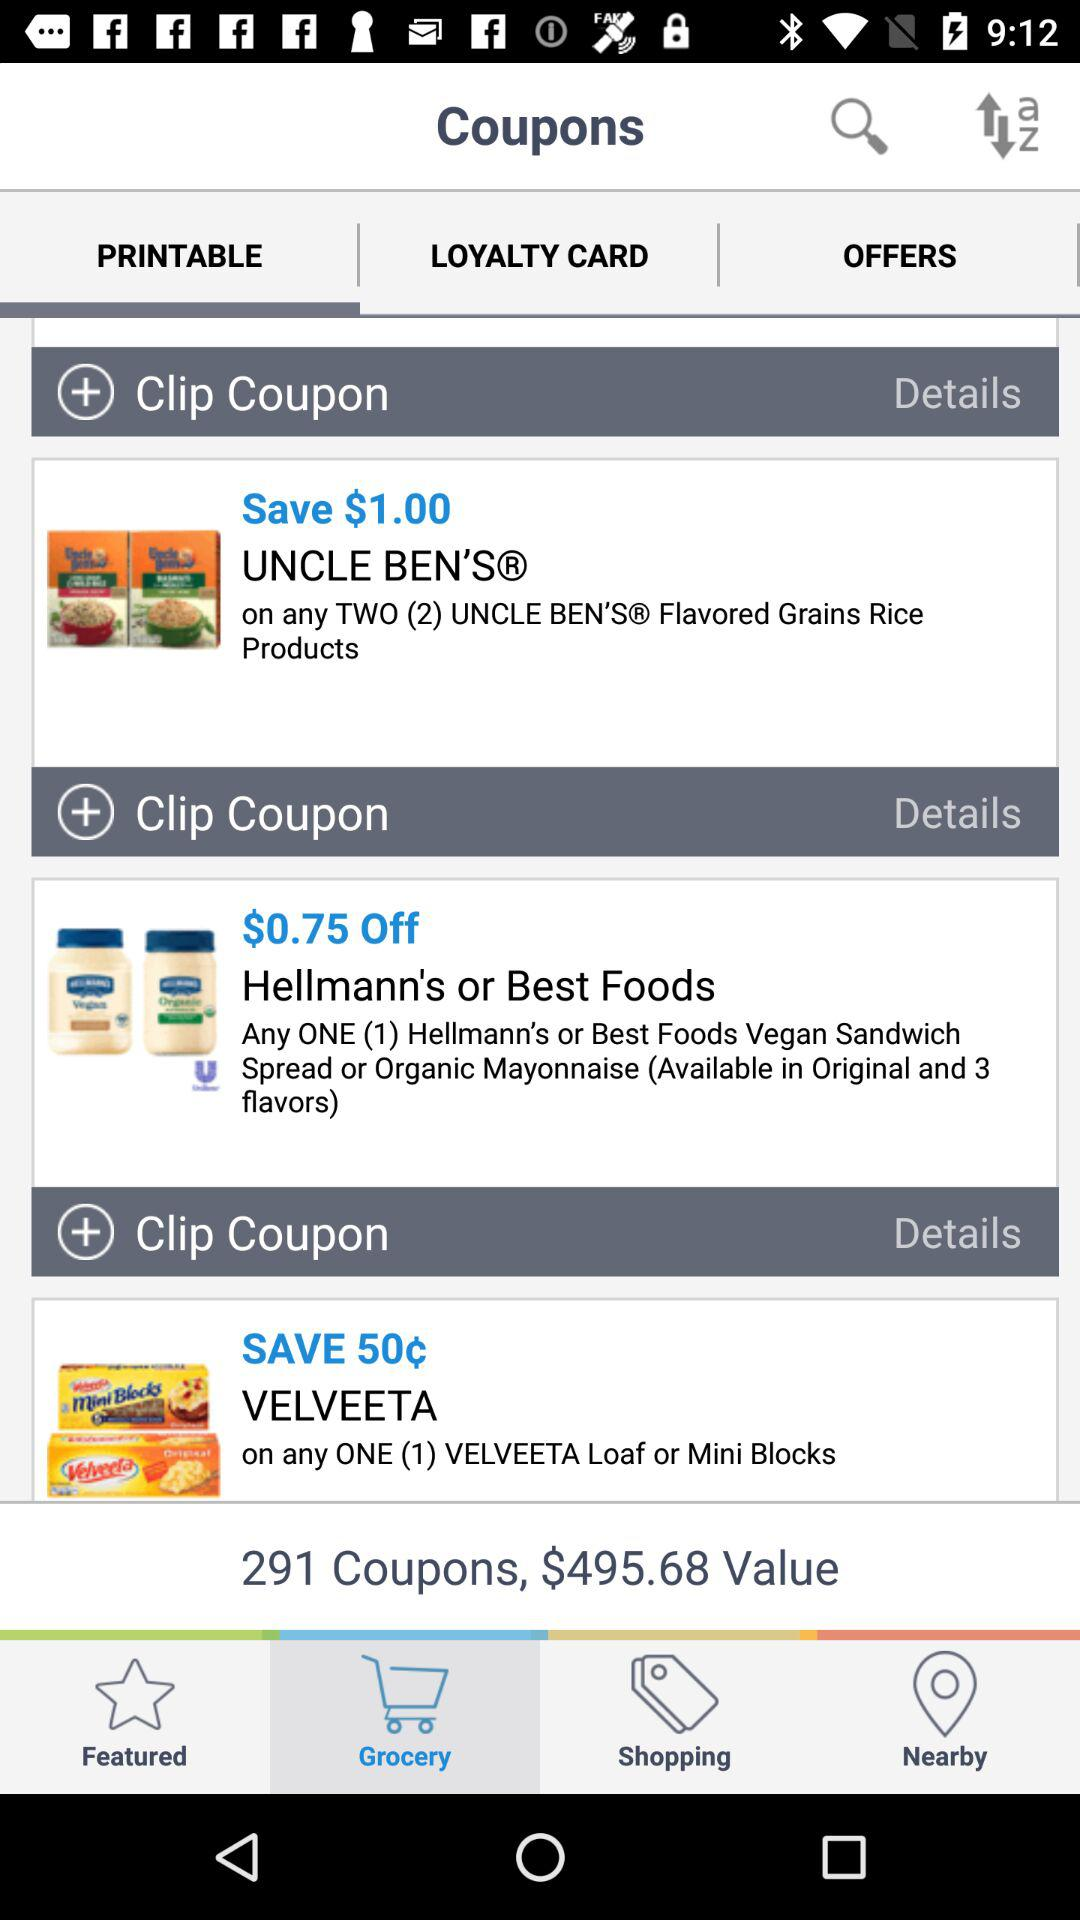How many coupons in total are there? There are 291 coupons. 